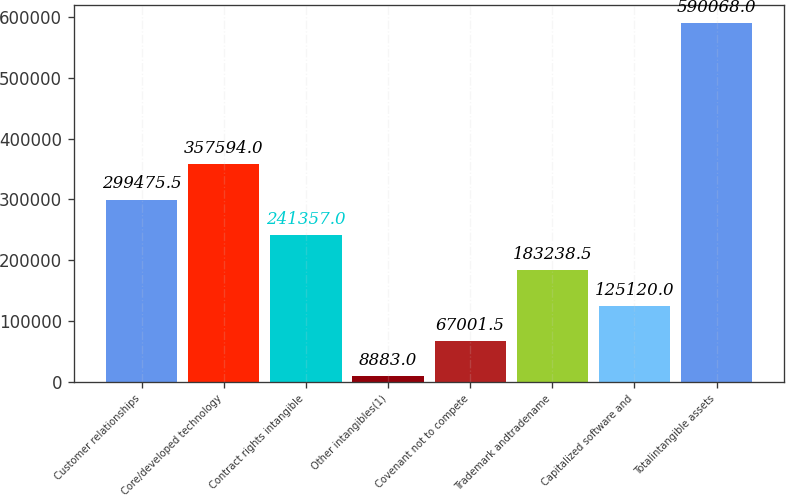<chart> <loc_0><loc_0><loc_500><loc_500><bar_chart><fcel>Customer relationships<fcel>Core/developed technology<fcel>Contract rights intangible<fcel>Other intangibles(1)<fcel>Covenant not to compete<fcel>Trademark andtradename<fcel>Capitalized software and<fcel>Totalintangible assets<nl><fcel>299476<fcel>357594<fcel>241357<fcel>8883<fcel>67001.5<fcel>183238<fcel>125120<fcel>590068<nl></chart> 